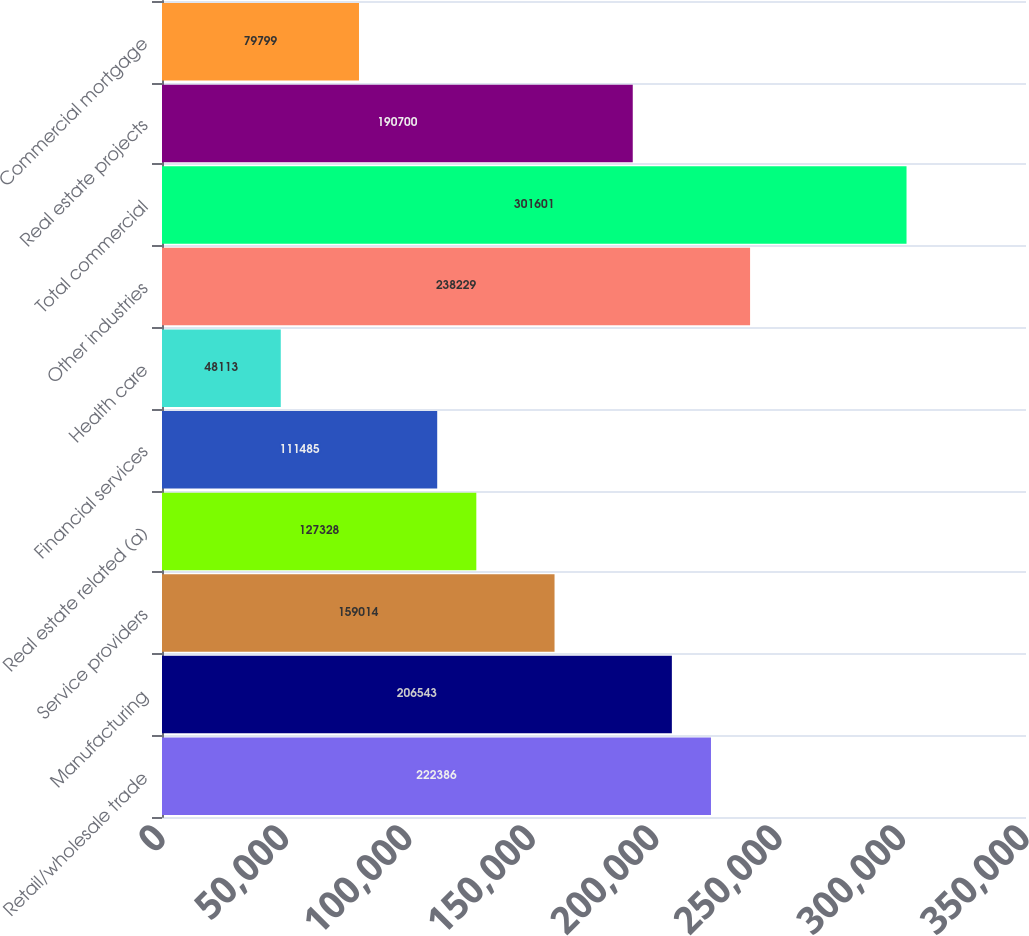<chart> <loc_0><loc_0><loc_500><loc_500><bar_chart><fcel>Retail/wholesale trade<fcel>Manufacturing<fcel>Service providers<fcel>Real estate related (a)<fcel>Financial services<fcel>Health care<fcel>Other industries<fcel>Total commercial<fcel>Real estate projects<fcel>Commercial mortgage<nl><fcel>222386<fcel>206543<fcel>159014<fcel>127328<fcel>111485<fcel>48113<fcel>238229<fcel>301601<fcel>190700<fcel>79799<nl></chart> 